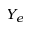Convert formula to latex. <formula><loc_0><loc_0><loc_500><loc_500>Y _ { e }</formula> 